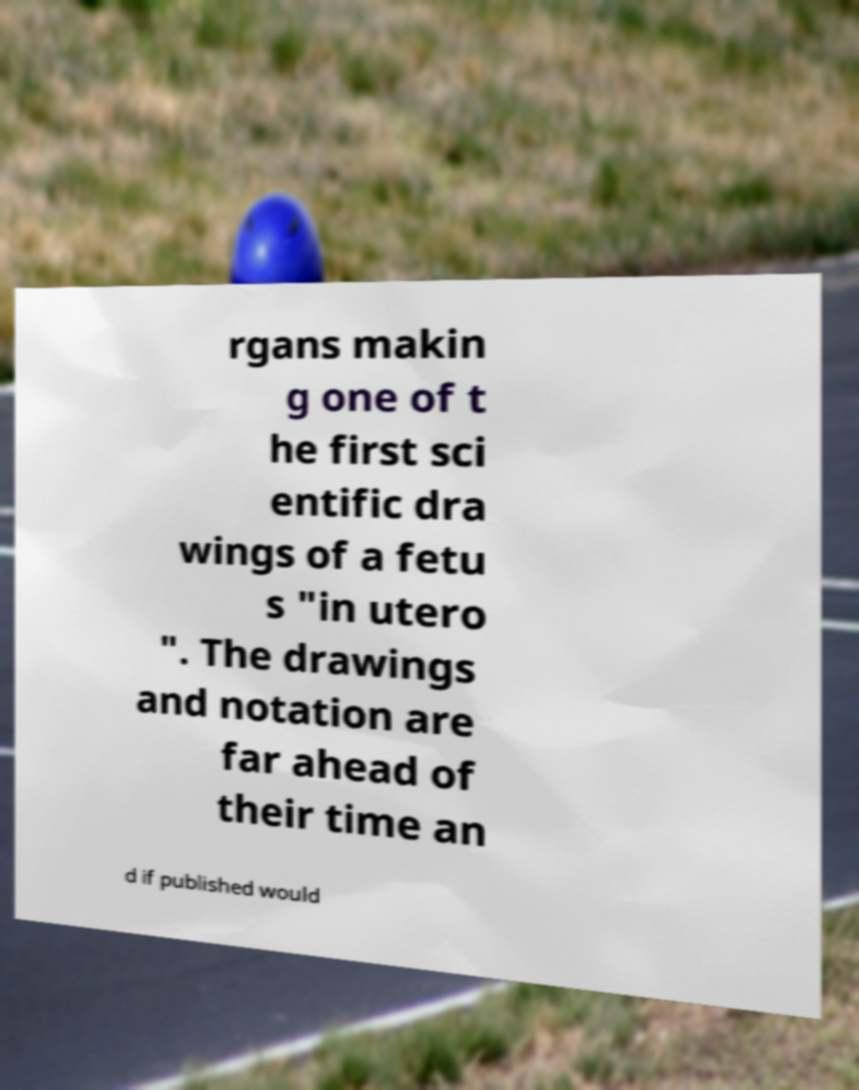Could you extract and type out the text from this image? rgans makin g one of t he first sci entific dra wings of a fetu s "in utero ". The drawings and notation are far ahead of their time an d if published would 